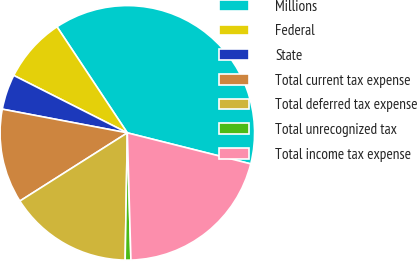Convert chart. <chart><loc_0><loc_0><loc_500><loc_500><pie_chart><fcel>Millions<fcel>Federal<fcel>State<fcel>Total current tax expense<fcel>Total deferred tax expense<fcel>Total unrecognized tax<fcel>Total income tax expense<nl><fcel>38.24%<fcel>8.23%<fcel>4.47%<fcel>11.98%<fcel>15.73%<fcel>0.72%<fcel>20.63%<nl></chart> 